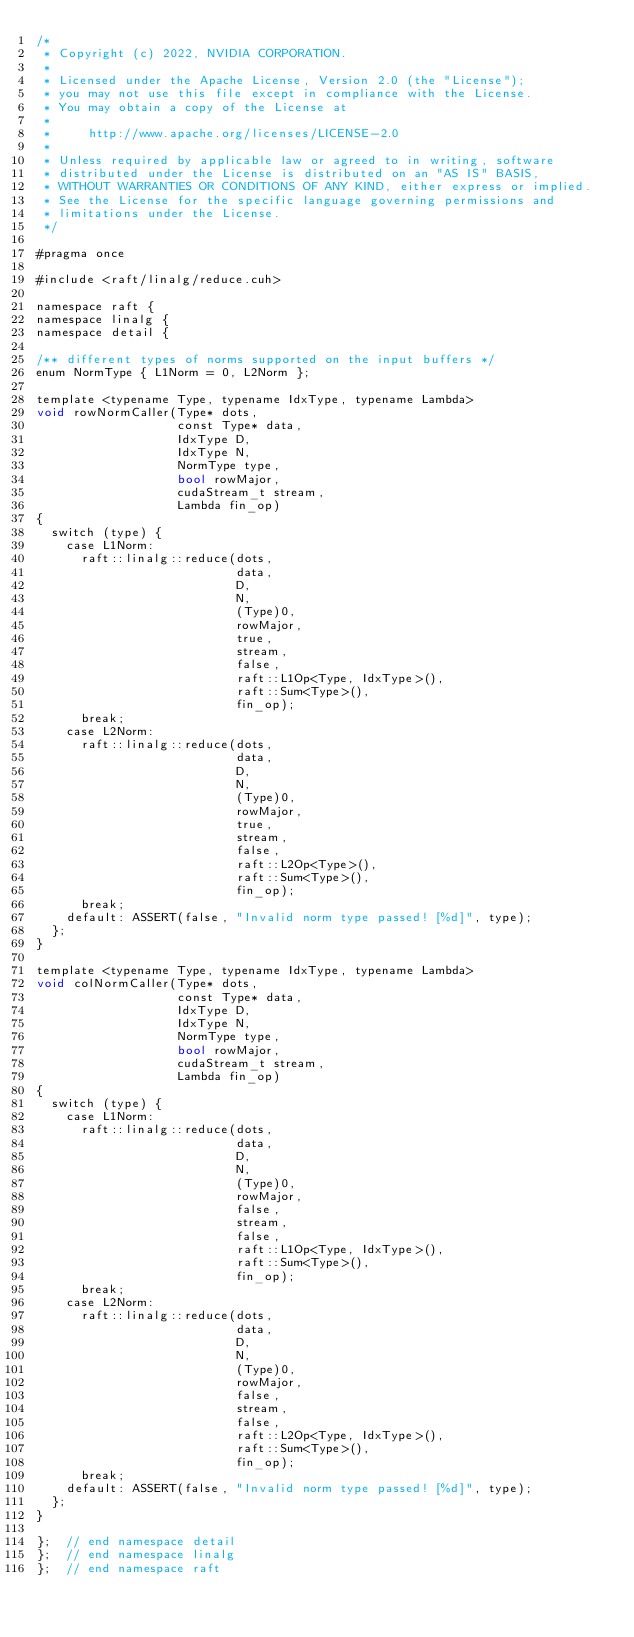<code> <loc_0><loc_0><loc_500><loc_500><_Cuda_>/*
 * Copyright (c) 2022, NVIDIA CORPORATION.
 *
 * Licensed under the Apache License, Version 2.0 (the "License");
 * you may not use this file except in compliance with the License.
 * You may obtain a copy of the License at
 *
 *     http://www.apache.org/licenses/LICENSE-2.0
 *
 * Unless required by applicable law or agreed to in writing, software
 * distributed under the License is distributed on an "AS IS" BASIS,
 * WITHOUT WARRANTIES OR CONDITIONS OF ANY KIND, either express or implied.
 * See the License for the specific language governing permissions and
 * limitations under the License.
 */

#pragma once

#include <raft/linalg/reduce.cuh>

namespace raft {
namespace linalg {
namespace detail {

/** different types of norms supported on the input buffers */
enum NormType { L1Norm = 0, L2Norm };

template <typename Type, typename IdxType, typename Lambda>
void rowNormCaller(Type* dots,
                   const Type* data,
                   IdxType D,
                   IdxType N,
                   NormType type,
                   bool rowMajor,
                   cudaStream_t stream,
                   Lambda fin_op)
{
  switch (type) {
    case L1Norm:
      raft::linalg::reduce(dots,
                           data,
                           D,
                           N,
                           (Type)0,
                           rowMajor,
                           true,
                           stream,
                           false,
                           raft::L1Op<Type, IdxType>(),
                           raft::Sum<Type>(),
                           fin_op);
      break;
    case L2Norm:
      raft::linalg::reduce(dots,
                           data,
                           D,
                           N,
                           (Type)0,
                           rowMajor,
                           true,
                           stream,
                           false,
                           raft::L2Op<Type>(),
                           raft::Sum<Type>(),
                           fin_op);
      break;
    default: ASSERT(false, "Invalid norm type passed! [%d]", type);
  };
}

template <typename Type, typename IdxType, typename Lambda>
void colNormCaller(Type* dots,
                   const Type* data,
                   IdxType D,
                   IdxType N,
                   NormType type,
                   bool rowMajor,
                   cudaStream_t stream,
                   Lambda fin_op)
{
  switch (type) {
    case L1Norm:
      raft::linalg::reduce(dots,
                           data,
                           D,
                           N,
                           (Type)0,
                           rowMajor,
                           false,
                           stream,
                           false,
                           raft::L1Op<Type, IdxType>(),
                           raft::Sum<Type>(),
                           fin_op);
      break;
    case L2Norm:
      raft::linalg::reduce(dots,
                           data,
                           D,
                           N,
                           (Type)0,
                           rowMajor,
                           false,
                           stream,
                           false,
                           raft::L2Op<Type, IdxType>(),
                           raft::Sum<Type>(),
                           fin_op);
      break;
    default: ASSERT(false, "Invalid norm type passed! [%d]", type);
  };
}

};  // end namespace detail
};  // end namespace linalg
};  // end namespace raft
</code> 